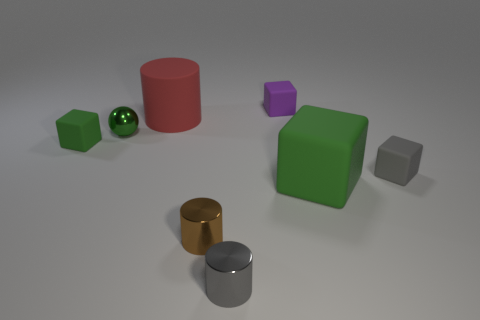There is a small block that is behind the cube that is on the left side of the tiny metallic thing that is in front of the brown shiny cylinder; what color is it?
Ensure brevity in your answer.  Purple. How many objects are small gray rubber cubes or tiny green spheres?
Ensure brevity in your answer.  2. How many small purple rubber objects have the same shape as the tiny gray metallic object?
Offer a very short reply. 0. Is the gray cube made of the same material as the large object that is in front of the tiny gray block?
Provide a succinct answer. Yes. The green ball that is the same material as the brown cylinder is what size?
Make the answer very short. Small. There is a green rubber block in front of the gray block; what size is it?
Ensure brevity in your answer.  Large. What number of cyan objects have the same size as the purple cube?
Give a very brief answer. 0. What is the size of the other cube that is the same color as the big matte block?
Your answer should be compact. Small. Is there another big matte cylinder that has the same color as the big cylinder?
Your answer should be compact. No. The metal sphere that is the same size as the gray matte block is what color?
Your response must be concise. Green. 